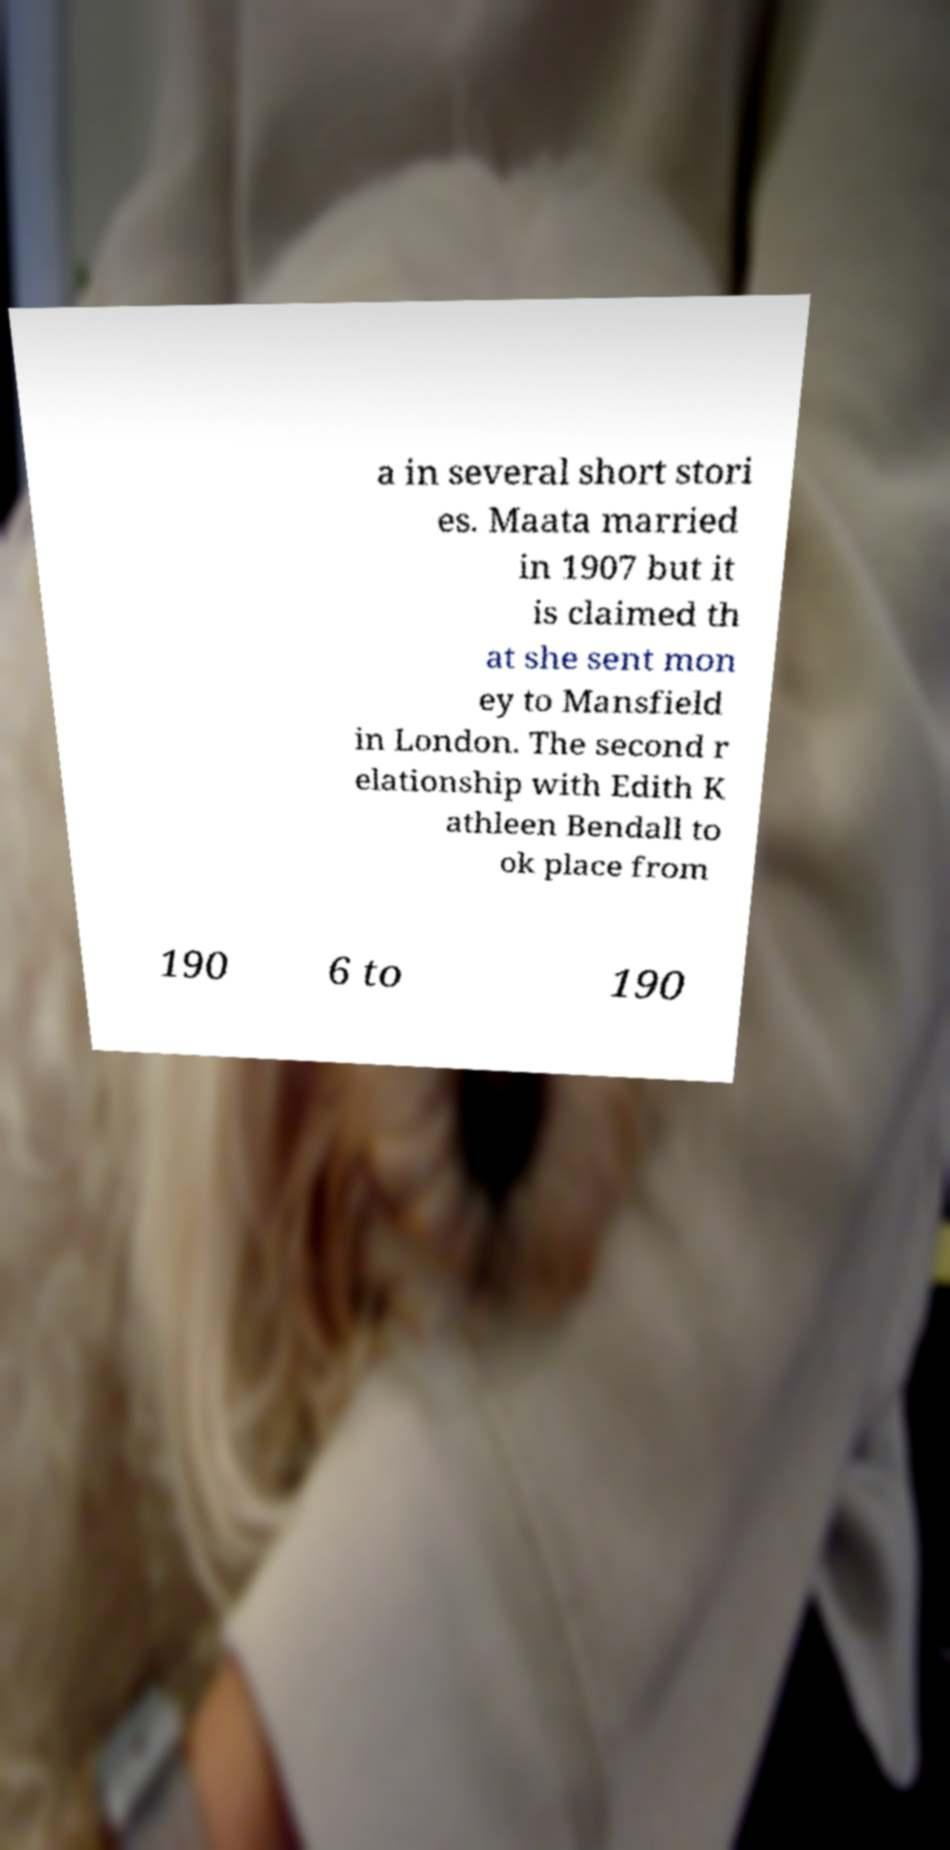What messages or text are displayed in this image? I need them in a readable, typed format. a in several short stori es. Maata married in 1907 but it is claimed th at she sent mon ey to Mansfield in London. The second r elationship with Edith K athleen Bendall to ok place from 190 6 to 190 